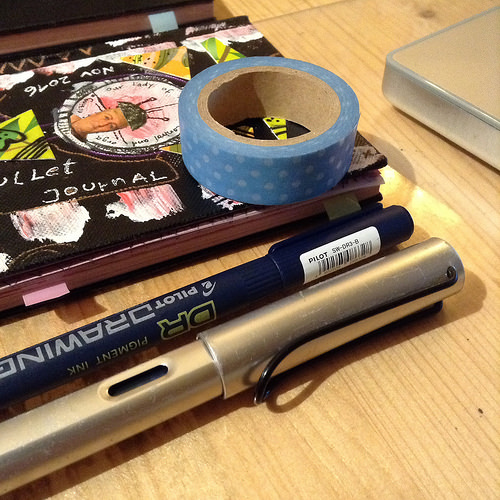<image>
Is the book to the left of the pen? Yes. From this viewpoint, the book is positioned to the left side relative to the pen. 